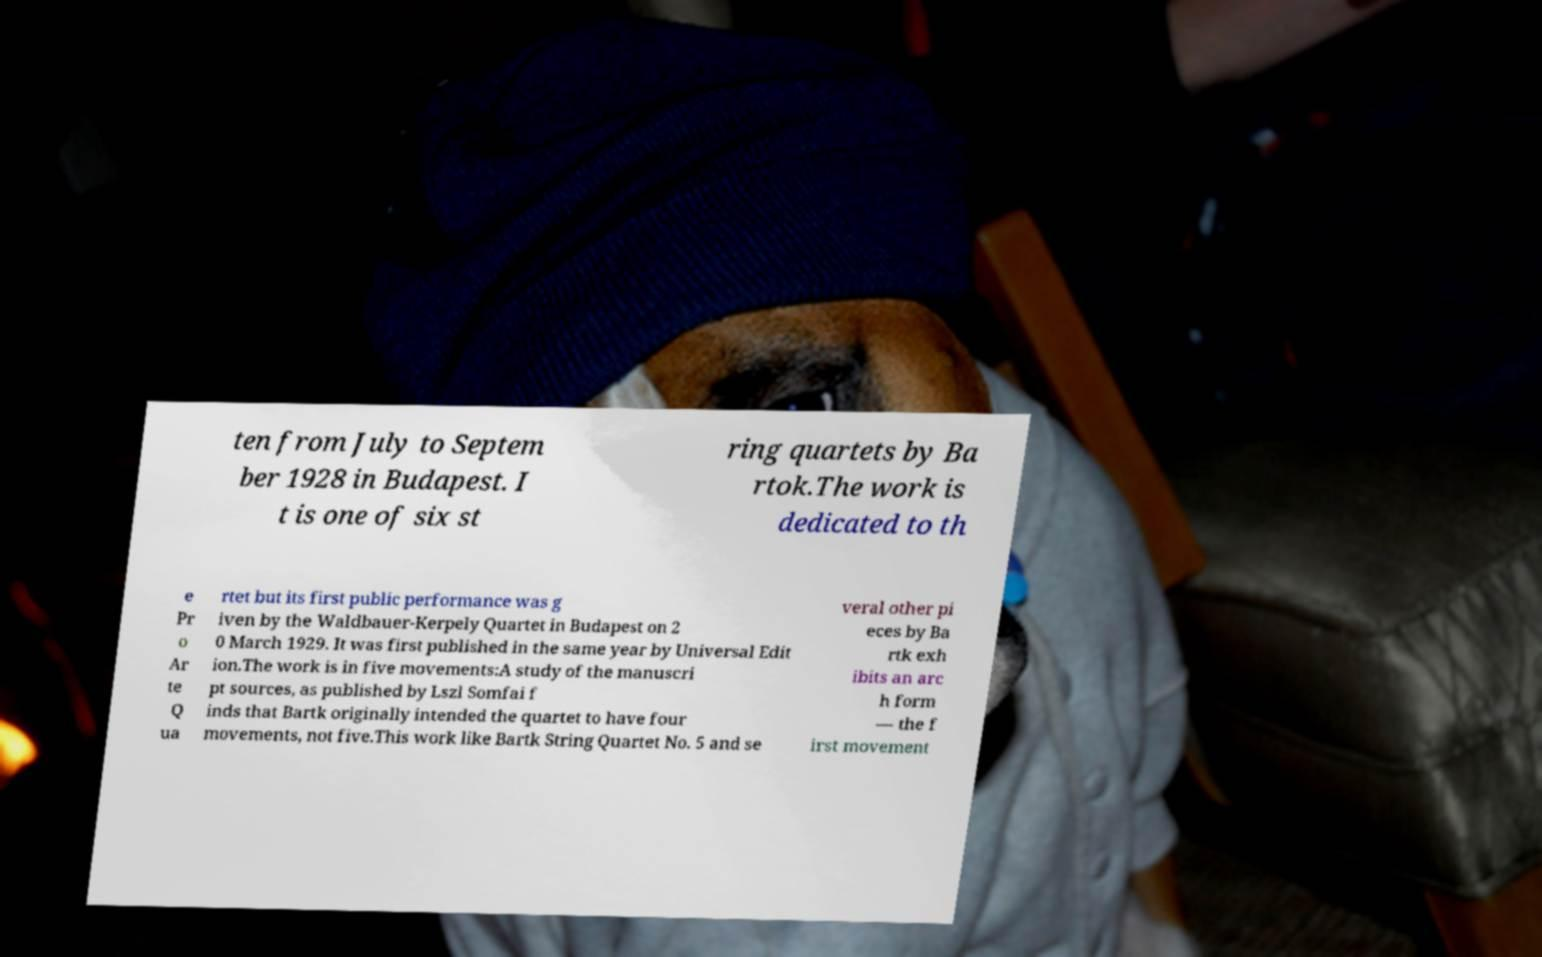There's text embedded in this image that I need extracted. Can you transcribe it verbatim? ten from July to Septem ber 1928 in Budapest. I t is one of six st ring quartets by Ba rtok.The work is dedicated to th e Pr o Ar te Q ua rtet but its first public performance was g iven by the Waldbauer-Kerpely Quartet in Budapest on 2 0 March 1929. It was first published in the same year by Universal Edit ion.The work is in five movements:A study of the manuscri pt sources, as published by Lszl Somfai f inds that Bartk originally intended the quartet to have four movements, not five.This work like Bartk String Quartet No. 5 and se veral other pi eces by Ba rtk exh ibits an arc h form — the f irst movement 